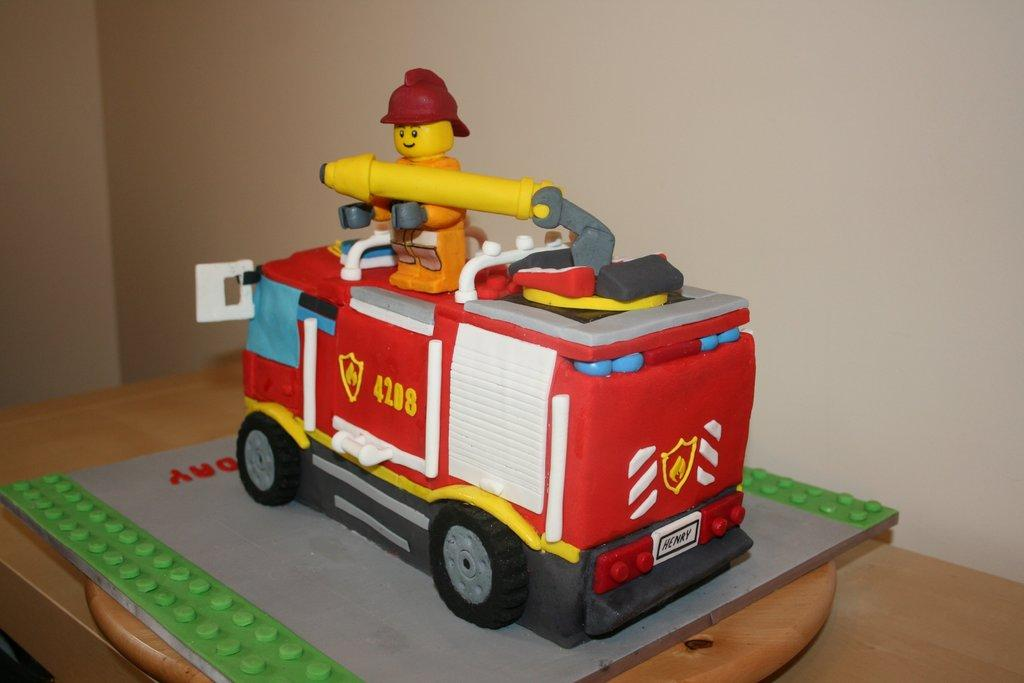What is the main subject of the image? There is a cake in the image. What is the cake placed on? The cake is on a wooden board. What is the theme of the wooden board? The wooden board has a Lego board theme. What can be seen in the background of the image? There is a wall in the background of the image. How does the family wash the hill in the image? There is no family, washing, or hill present in the image; it features a cake on a wooden board with a Lego board theme and a wall in the background. 